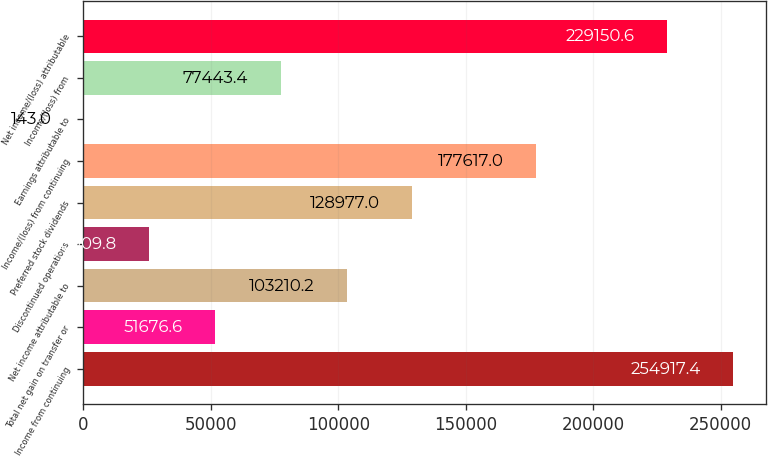Convert chart to OTSL. <chart><loc_0><loc_0><loc_500><loc_500><bar_chart><fcel>Income from continuing<fcel>Total net gain on transfer or<fcel>Net income attributable to<fcel>Discontinued operations<fcel>Preferred stock dividends<fcel>Income/(loss) from continuing<fcel>Earnings attributable to<fcel>Income/(loss) from<fcel>Net income/(loss) attributable<nl><fcel>254917<fcel>51676.6<fcel>103210<fcel>25909.8<fcel>128977<fcel>177617<fcel>143<fcel>77443.4<fcel>229151<nl></chart> 